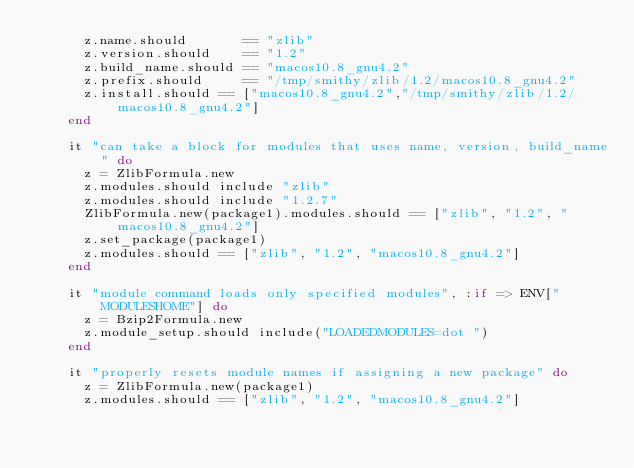<code> <loc_0><loc_0><loc_500><loc_500><_Ruby_>      z.name.should       == "zlib"
      z.version.should    == "1.2"
      z.build_name.should == "macos10.8_gnu4.2"
      z.prefix.should     == "/tmp/smithy/zlib/1.2/macos10.8_gnu4.2"
      z.install.should == ["macos10.8_gnu4.2","/tmp/smithy/zlib/1.2/macos10.8_gnu4.2"]
    end

    it "can take a block for modules that uses name, version, build_name" do
      z = ZlibFormula.new
      z.modules.should include "zlib"
      z.modules.should include "1.2.7"
      ZlibFormula.new(package1).modules.should == ["zlib", "1.2", "macos10.8_gnu4.2"]
      z.set_package(package1)
      z.modules.should == ["zlib", "1.2", "macos10.8_gnu4.2"]
    end

    it "module command loads only specified modules", :if => ENV["MODULESHOME"] do
      z = Bzip2Formula.new
      z.module_setup.should include("LOADEDMODULES=dot ")
    end

    it "properly resets module names if assigning a new package" do
      z = ZlibFormula.new(package1)
      z.modules.should == ["zlib", "1.2", "macos10.8_gnu4.2"]</code> 